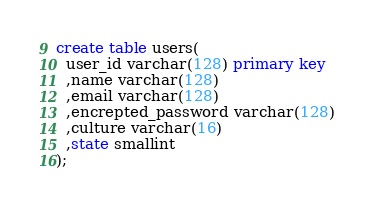<code> <loc_0><loc_0><loc_500><loc_500><_SQL_>
create table users(
  user_id varchar(128) primary key
  ,name varchar(128)
  ,email varchar(128)
  ,encrepted_password varchar(128)
  ,culture varchar(16)
  ,state smallint
);
</code> 